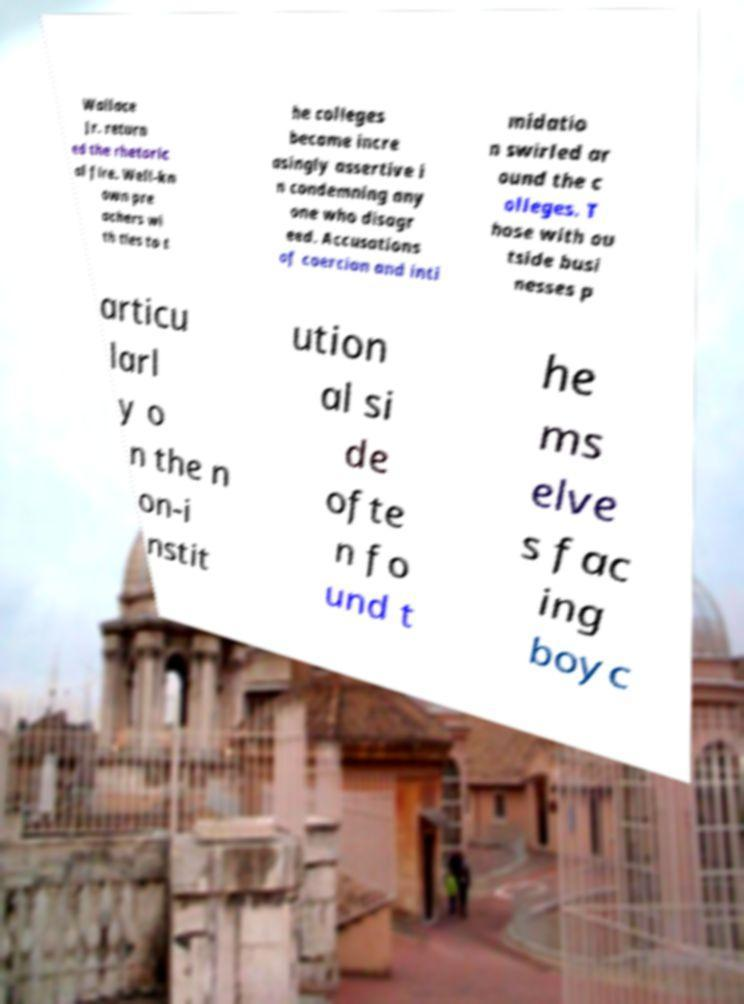I need the written content from this picture converted into text. Can you do that? Wallace Jr. return ed the rhetoric al fire. Well-kn own pre achers wi th ties to t he colleges became incre asingly assertive i n condemning any one who disagr eed. Accusations of coercion and inti midatio n swirled ar ound the c olleges. T hose with ou tside busi nesses p articu larl y o n the n on-i nstit ution al si de ofte n fo und t he ms elve s fac ing boyc 